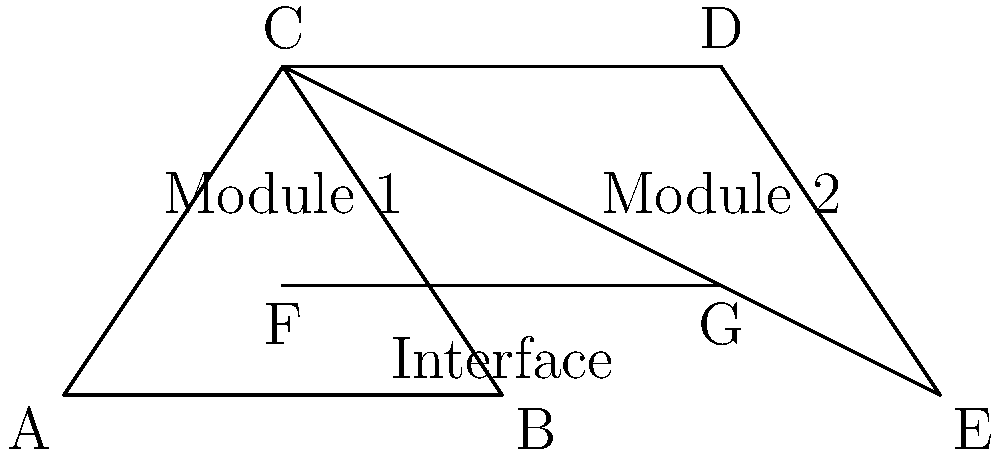In the software architecture diagram above, which two triangles are congruent, and what property of congruence can be used to prove this? To identify congruent triangles in this software architecture diagram, we need to follow these steps:

1. Identify the triangles: We have two triangles, $\triangle ABC$ and $\triangle CDE$.

2. Compare the sides and angles of the triangles:
   a. $\overline{AC} \cong \overline{CD}$ (shared side)
   b. $\overline{AB} \cong \overline{DE}$ (base of each triangle, appears equal)
   c. $\angle BAC \cong \angle EDC$ (appear to be equal angles)

3. Apply the SAS (Side-Angle-Side) congruence property:
   - We have two pairs of congruent sides ($\overline{AC} \cong \overline{CD}$ and $\overline{AB} \cong \overline{DE}$)
   - We have a pair of congruent included angles ($\angle BAC \cong \angle EDC$)

4. Conclusion: $\triangle ABC \cong \triangle CDE$ by the SAS congruence property

This congruence in the diagram could represent similar modules or components in the software architecture with equivalent structures or relationships.
Answer: $\triangle ABC \cong \triangle CDE$ by SAS 